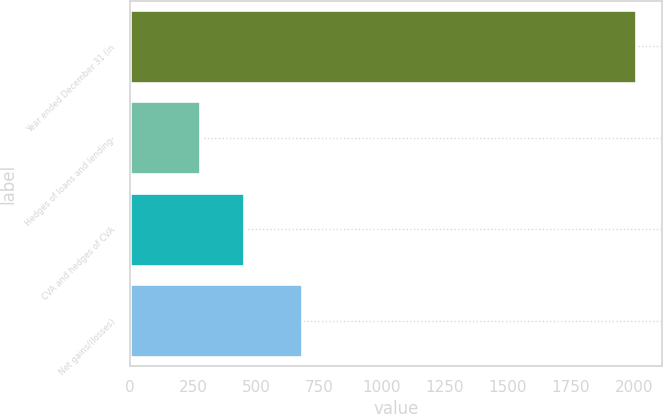Convert chart. <chart><loc_0><loc_0><loc_500><loc_500><bar_chart><fcel>Year ended December 31 (in<fcel>Hedges of loans and lending-<fcel>CVA and hedges of CVA<fcel>Net gains/(losses)<nl><fcel>2010<fcel>279<fcel>452.1<fcel>682<nl></chart> 